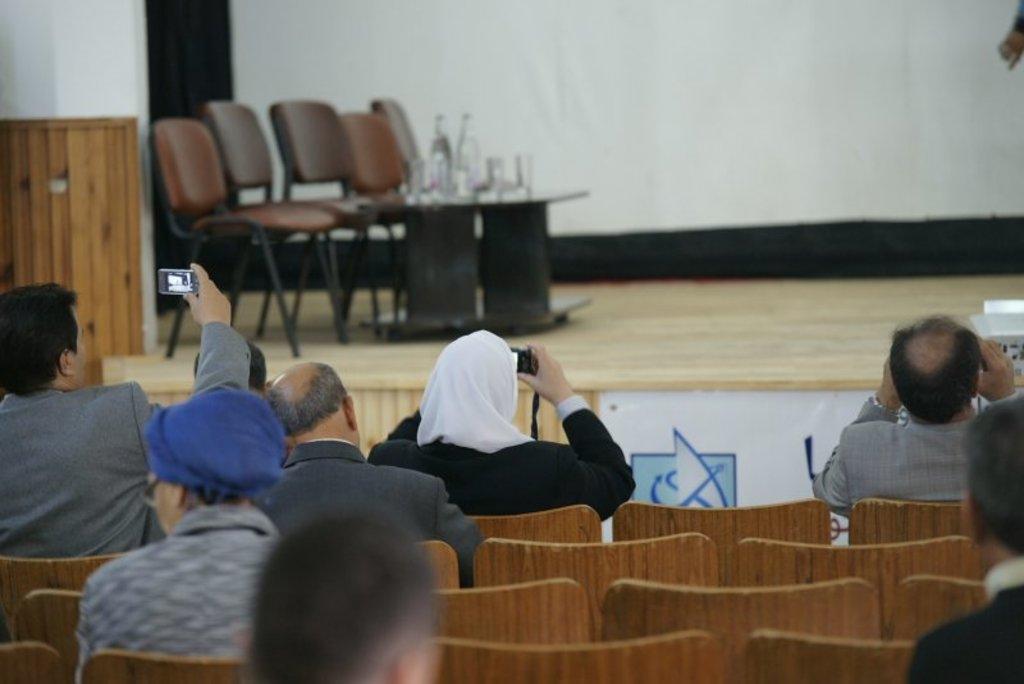Could you give a brief overview of what you see in this image? In the image we can see there are people who are sitting on chair and holding camera in their hand. On the stage there are chairs and table. 